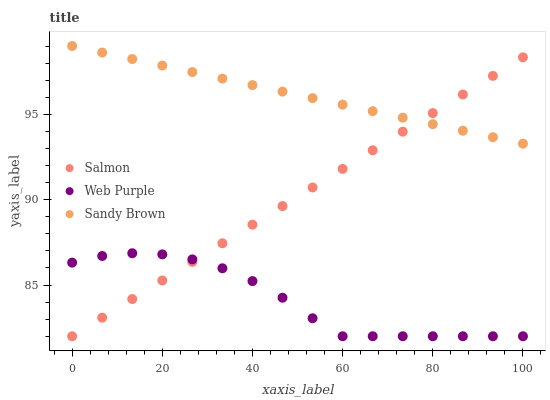Does Web Purple have the minimum area under the curve?
Answer yes or no. Yes. Does Sandy Brown have the maximum area under the curve?
Answer yes or no. Yes. Does Salmon have the minimum area under the curve?
Answer yes or no. No. Does Salmon have the maximum area under the curve?
Answer yes or no. No. Is Sandy Brown the smoothest?
Answer yes or no. Yes. Is Web Purple the roughest?
Answer yes or no. Yes. Is Salmon the smoothest?
Answer yes or no. No. Is Salmon the roughest?
Answer yes or no. No. Does Web Purple have the lowest value?
Answer yes or no. Yes. Does Sandy Brown have the highest value?
Answer yes or no. Yes. Does Salmon have the highest value?
Answer yes or no. No. Is Web Purple less than Sandy Brown?
Answer yes or no. Yes. Is Sandy Brown greater than Web Purple?
Answer yes or no. Yes. Does Salmon intersect Sandy Brown?
Answer yes or no. Yes. Is Salmon less than Sandy Brown?
Answer yes or no. No. Is Salmon greater than Sandy Brown?
Answer yes or no. No. Does Web Purple intersect Sandy Brown?
Answer yes or no. No. 